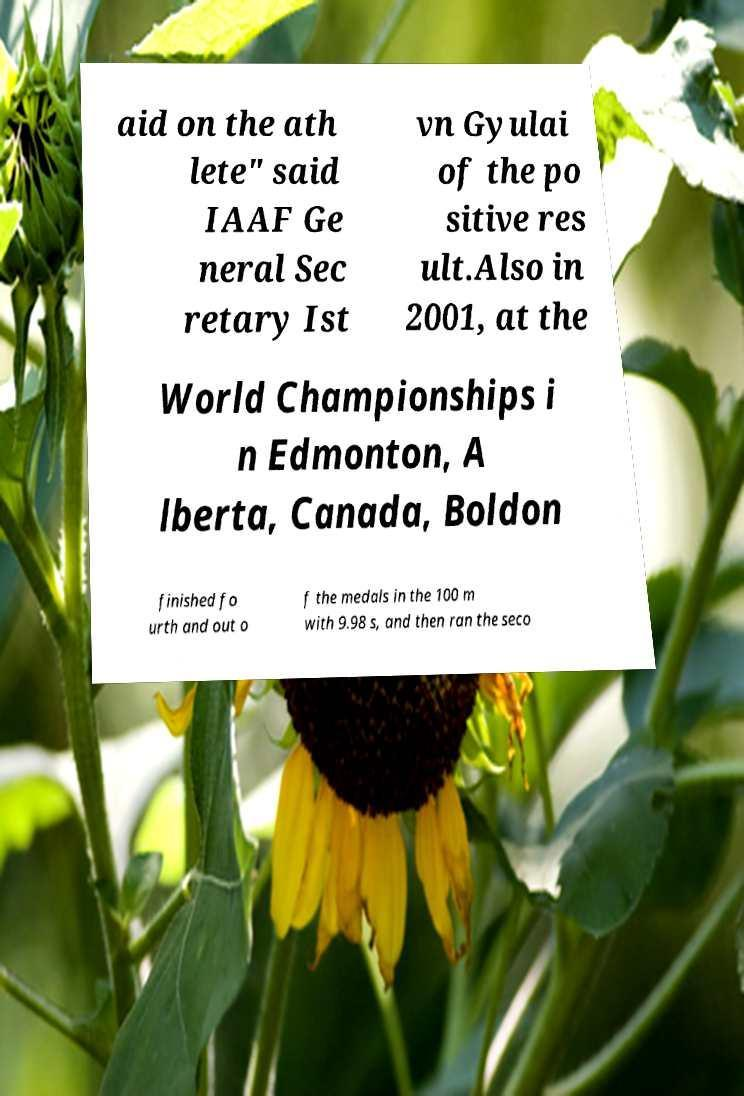What messages or text are displayed in this image? I need them in a readable, typed format. aid on the ath lete" said IAAF Ge neral Sec retary Ist vn Gyulai of the po sitive res ult.Also in 2001, at the World Championships i n Edmonton, A lberta, Canada, Boldon finished fo urth and out o f the medals in the 100 m with 9.98 s, and then ran the seco 